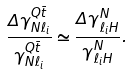<formula> <loc_0><loc_0><loc_500><loc_500>\frac { \Delta \gamma ^ { Q \bar { t } } _ { N \ell _ { i } } } { \gamma ^ { Q \bar { t } } _ { N \ell _ { i } } } \simeq \frac { \Delta \gamma ^ { N } _ { \ell _ { i } H } } { \gamma ^ { N } _ { \ell _ { i } H } } .</formula> 